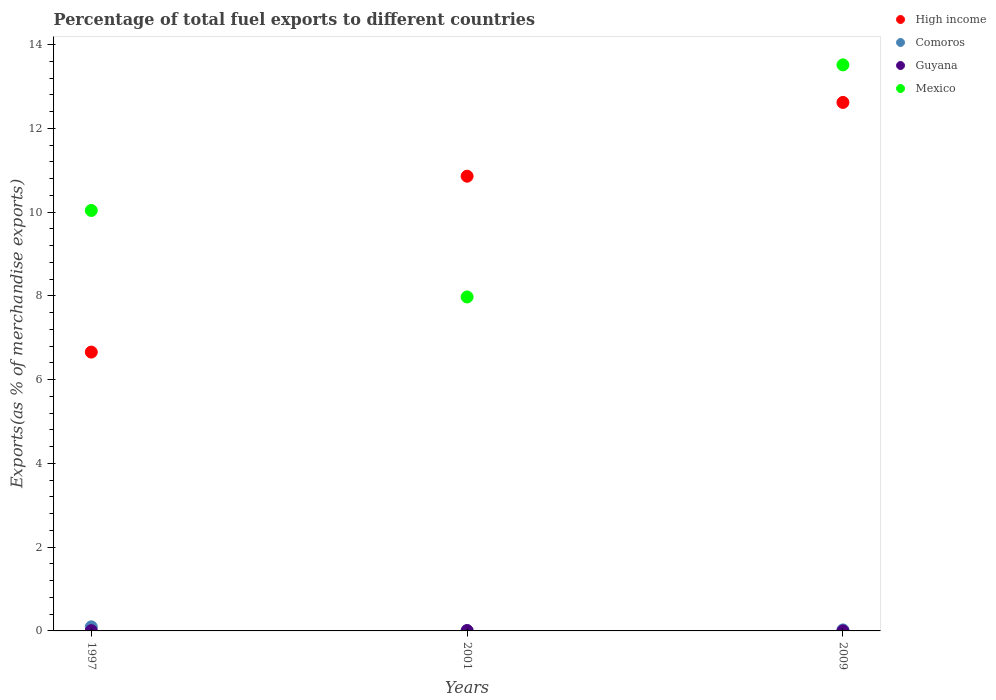Is the number of dotlines equal to the number of legend labels?
Your answer should be very brief. Yes. What is the percentage of exports to different countries in High income in 2009?
Give a very brief answer. 12.62. Across all years, what is the maximum percentage of exports to different countries in Mexico?
Keep it short and to the point. 13.51. Across all years, what is the minimum percentage of exports to different countries in Comoros?
Ensure brevity in your answer.  0. What is the total percentage of exports to different countries in Mexico in the graph?
Offer a terse response. 31.53. What is the difference between the percentage of exports to different countries in Comoros in 1997 and that in 2001?
Offer a terse response. 0.09. What is the difference between the percentage of exports to different countries in Mexico in 1997 and the percentage of exports to different countries in High income in 2001?
Give a very brief answer. -0.82. What is the average percentage of exports to different countries in Mexico per year?
Offer a very short reply. 10.51. In the year 2001, what is the difference between the percentage of exports to different countries in High income and percentage of exports to different countries in Guyana?
Keep it short and to the point. 10.85. In how many years, is the percentage of exports to different countries in High income greater than 12.8 %?
Your response must be concise. 0. What is the ratio of the percentage of exports to different countries in High income in 2001 to that in 2009?
Offer a very short reply. 0.86. Is the percentage of exports to different countries in Mexico in 1997 less than that in 2001?
Give a very brief answer. No. Is the difference between the percentage of exports to different countries in High income in 1997 and 2001 greater than the difference between the percentage of exports to different countries in Guyana in 1997 and 2001?
Ensure brevity in your answer.  No. What is the difference between the highest and the second highest percentage of exports to different countries in High income?
Offer a terse response. 1.76. What is the difference between the highest and the lowest percentage of exports to different countries in Mexico?
Your answer should be compact. 5.54. In how many years, is the percentage of exports to different countries in Guyana greater than the average percentage of exports to different countries in Guyana taken over all years?
Give a very brief answer. 2. Is it the case that in every year, the sum of the percentage of exports to different countries in Guyana and percentage of exports to different countries in Comoros  is greater than the sum of percentage of exports to different countries in High income and percentage of exports to different countries in Mexico?
Ensure brevity in your answer.  No. Is it the case that in every year, the sum of the percentage of exports to different countries in Guyana and percentage of exports to different countries in Comoros  is greater than the percentage of exports to different countries in Mexico?
Offer a very short reply. No. Does the percentage of exports to different countries in Mexico monotonically increase over the years?
Provide a succinct answer. No. Is the percentage of exports to different countries in High income strictly less than the percentage of exports to different countries in Guyana over the years?
Your answer should be compact. No. How many dotlines are there?
Offer a very short reply. 4. What is the difference between two consecutive major ticks on the Y-axis?
Offer a terse response. 2. Does the graph contain grids?
Offer a terse response. No. How are the legend labels stacked?
Offer a very short reply. Vertical. What is the title of the graph?
Offer a terse response. Percentage of total fuel exports to different countries. Does "Arab World" appear as one of the legend labels in the graph?
Make the answer very short. No. What is the label or title of the Y-axis?
Offer a very short reply. Exports(as % of merchandise exports). What is the Exports(as % of merchandise exports) in High income in 1997?
Your answer should be compact. 6.66. What is the Exports(as % of merchandise exports) in Comoros in 1997?
Make the answer very short. 0.1. What is the Exports(as % of merchandise exports) of Guyana in 1997?
Ensure brevity in your answer.  0.01. What is the Exports(as % of merchandise exports) in Mexico in 1997?
Ensure brevity in your answer.  10.04. What is the Exports(as % of merchandise exports) of High income in 2001?
Ensure brevity in your answer.  10.86. What is the Exports(as % of merchandise exports) of Comoros in 2001?
Give a very brief answer. 0. What is the Exports(as % of merchandise exports) in Guyana in 2001?
Your response must be concise. 0.01. What is the Exports(as % of merchandise exports) of Mexico in 2001?
Keep it short and to the point. 7.97. What is the Exports(as % of merchandise exports) in High income in 2009?
Your response must be concise. 12.62. What is the Exports(as % of merchandise exports) of Comoros in 2009?
Give a very brief answer. 0.02. What is the Exports(as % of merchandise exports) in Guyana in 2009?
Make the answer very short. 0. What is the Exports(as % of merchandise exports) in Mexico in 2009?
Offer a very short reply. 13.51. Across all years, what is the maximum Exports(as % of merchandise exports) in High income?
Your response must be concise. 12.62. Across all years, what is the maximum Exports(as % of merchandise exports) in Comoros?
Offer a terse response. 0.1. Across all years, what is the maximum Exports(as % of merchandise exports) in Guyana?
Give a very brief answer. 0.01. Across all years, what is the maximum Exports(as % of merchandise exports) in Mexico?
Keep it short and to the point. 13.51. Across all years, what is the minimum Exports(as % of merchandise exports) in High income?
Your response must be concise. 6.66. Across all years, what is the minimum Exports(as % of merchandise exports) of Comoros?
Keep it short and to the point. 0. Across all years, what is the minimum Exports(as % of merchandise exports) in Guyana?
Make the answer very short. 0. Across all years, what is the minimum Exports(as % of merchandise exports) of Mexico?
Give a very brief answer. 7.97. What is the total Exports(as % of merchandise exports) of High income in the graph?
Make the answer very short. 30.13. What is the total Exports(as % of merchandise exports) in Comoros in the graph?
Offer a very short reply. 0.13. What is the total Exports(as % of merchandise exports) in Guyana in the graph?
Keep it short and to the point. 0.01. What is the total Exports(as % of merchandise exports) of Mexico in the graph?
Your answer should be very brief. 31.53. What is the difference between the Exports(as % of merchandise exports) in High income in 1997 and that in 2001?
Provide a succinct answer. -4.2. What is the difference between the Exports(as % of merchandise exports) in Comoros in 1997 and that in 2001?
Ensure brevity in your answer.  0.09. What is the difference between the Exports(as % of merchandise exports) in Guyana in 1997 and that in 2001?
Ensure brevity in your answer.  -0. What is the difference between the Exports(as % of merchandise exports) in Mexico in 1997 and that in 2001?
Offer a terse response. 2.06. What is the difference between the Exports(as % of merchandise exports) of High income in 1997 and that in 2009?
Your answer should be very brief. -5.96. What is the difference between the Exports(as % of merchandise exports) in Comoros in 1997 and that in 2009?
Offer a very short reply. 0.07. What is the difference between the Exports(as % of merchandise exports) of Guyana in 1997 and that in 2009?
Your answer should be very brief. 0.01. What is the difference between the Exports(as % of merchandise exports) in Mexico in 1997 and that in 2009?
Your response must be concise. -3.48. What is the difference between the Exports(as % of merchandise exports) in High income in 2001 and that in 2009?
Provide a short and direct response. -1.76. What is the difference between the Exports(as % of merchandise exports) of Comoros in 2001 and that in 2009?
Provide a succinct answer. -0.02. What is the difference between the Exports(as % of merchandise exports) of Guyana in 2001 and that in 2009?
Give a very brief answer. 0.01. What is the difference between the Exports(as % of merchandise exports) of Mexico in 2001 and that in 2009?
Make the answer very short. -5.54. What is the difference between the Exports(as % of merchandise exports) in High income in 1997 and the Exports(as % of merchandise exports) in Comoros in 2001?
Keep it short and to the point. 6.65. What is the difference between the Exports(as % of merchandise exports) of High income in 1997 and the Exports(as % of merchandise exports) of Guyana in 2001?
Keep it short and to the point. 6.65. What is the difference between the Exports(as % of merchandise exports) of High income in 1997 and the Exports(as % of merchandise exports) of Mexico in 2001?
Provide a short and direct response. -1.32. What is the difference between the Exports(as % of merchandise exports) in Comoros in 1997 and the Exports(as % of merchandise exports) in Guyana in 2001?
Provide a succinct answer. 0.09. What is the difference between the Exports(as % of merchandise exports) of Comoros in 1997 and the Exports(as % of merchandise exports) of Mexico in 2001?
Your answer should be compact. -7.88. What is the difference between the Exports(as % of merchandise exports) of Guyana in 1997 and the Exports(as % of merchandise exports) of Mexico in 2001?
Keep it short and to the point. -7.97. What is the difference between the Exports(as % of merchandise exports) of High income in 1997 and the Exports(as % of merchandise exports) of Comoros in 2009?
Provide a short and direct response. 6.63. What is the difference between the Exports(as % of merchandise exports) of High income in 1997 and the Exports(as % of merchandise exports) of Guyana in 2009?
Offer a very short reply. 6.66. What is the difference between the Exports(as % of merchandise exports) in High income in 1997 and the Exports(as % of merchandise exports) in Mexico in 2009?
Provide a succinct answer. -6.86. What is the difference between the Exports(as % of merchandise exports) of Comoros in 1997 and the Exports(as % of merchandise exports) of Guyana in 2009?
Ensure brevity in your answer.  0.1. What is the difference between the Exports(as % of merchandise exports) in Comoros in 1997 and the Exports(as % of merchandise exports) in Mexico in 2009?
Provide a succinct answer. -13.42. What is the difference between the Exports(as % of merchandise exports) in Guyana in 1997 and the Exports(as % of merchandise exports) in Mexico in 2009?
Provide a short and direct response. -13.51. What is the difference between the Exports(as % of merchandise exports) in High income in 2001 and the Exports(as % of merchandise exports) in Comoros in 2009?
Your answer should be very brief. 10.83. What is the difference between the Exports(as % of merchandise exports) in High income in 2001 and the Exports(as % of merchandise exports) in Guyana in 2009?
Your answer should be very brief. 10.86. What is the difference between the Exports(as % of merchandise exports) in High income in 2001 and the Exports(as % of merchandise exports) in Mexico in 2009?
Offer a terse response. -2.66. What is the difference between the Exports(as % of merchandise exports) of Comoros in 2001 and the Exports(as % of merchandise exports) of Guyana in 2009?
Your answer should be very brief. 0. What is the difference between the Exports(as % of merchandise exports) of Comoros in 2001 and the Exports(as % of merchandise exports) of Mexico in 2009?
Provide a succinct answer. -13.51. What is the difference between the Exports(as % of merchandise exports) in Guyana in 2001 and the Exports(as % of merchandise exports) in Mexico in 2009?
Your answer should be very brief. -13.51. What is the average Exports(as % of merchandise exports) of High income per year?
Ensure brevity in your answer.  10.04. What is the average Exports(as % of merchandise exports) in Comoros per year?
Provide a succinct answer. 0.04. What is the average Exports(as % of merchandise exports) in Guyana per year?
Offer a very short reply. 0. What is the average Exports(as % of merchandise exports) of Mexico per year?
Your answer should be compact. 10.51. In the year 1997, what is the difference between the Exports(as % of merchandise exports) in High income and Exports(as % of merchandise exports) in Comoros?
Your answer should be very brief. 6.56. In the year 1997, what is the difference between the Exports(as % of merchandise exports) in High income and Exports(as % of merchandise exports) in Guyana?
Provide a short and direct response. 6.65. In the year 1997, what is the difference between the Exports(as % of merchandise exports) in High income and Exports(as % of merchandise exports) in Mexico?
Make the answer very short. -3.38. In the year 1997, what is the difference between the Exports(as % of merchandise exports) in Comoros and Exports(as % of merchandise exports) in Guyana?
Ensure brevity in your answer.  0.09. In the year 1997, what is the difference between the Exports(as % of merchandise exports) in Comoros and Exports(as % of merchandise exports) in Mexico?
Your answer should be very brief. -9.94. In the year 1997, what is the difference between the Exports(as % of merchandise exports) in Guyana and Exports(as % of merchandise exports) in Mexico?
Provide a succinct answer. -10.03. In the year 2001, what is the difference between the Exports(as % of merchandise exports) in High income and Exports(as % of merchandise exports) in Comoros?
Provide a succinct answer. 10.85. In the year 2001, what is the difference between the Exports(as % of merchandise exports) in High income and Exports(as % of merchandise exports) in Guyana?
Offer a terse response. 10.85. In the year 2001, what is the difference between the Exports(as % of merchandise exports) in High income and Exports(as % of merchandise exports) in Mexico?
Keep it short and to the point. 2.88. In the year 2001, what is the difference between the Exports(as % of merchandise exports) in Comoros and Exports(as % of merchandise exports) in Guyana?
Provide a short and direct response. -0. In the year 2001, what is the difference between the Exports(as % of merchandise exports) in Comoros and Exports(as % of merchandise exports) in Mexico?
Keep it short and to the point. -7.97. In the year 2001, what is the difference between the Exports(as % of merchandise exports) in Guyana and Exports(as % of merchandise exports) in Mexico?
Your answer should be very brief. -7.97. In the year 2009, what is the difference between the Exports(as % of merchandise exports) of High income and Exports(as % of merchandise exports) of Comoros?
Offer a very short reply. 12.59. In the year 2009, what is the difference between the Exports(as % of merchandise exports) of High income and Exports(as % of merchandise exports) of Guyana?
Keep it short and to the point. 12.62. In the year 2009, what is the difference between the Exports(as % of merchandise exports) of High income and Exports(as % of merchandise exports) of Mexico?
Offer a very short reply. -0.9. In the year 2009, what is the difference between the Exports(as % of merchandise exports) of Comoros and Exports(as % of merchandise exports) of Guyana?
Your response must be concise. 0.02. In the year 2009, what is the difference between the Exports(as % of merchandise exports) of Comoros and Exports(as % of merchandise exports) of Mexico?
Keep it short and to the point. -13.49. In the year 2009, what is the difference between the Exports(as % of merchandise exports) of Guyana and Exports(as % of merchandise exports) of Mexico?
Your response must be concise. -13.51. What is the ratio of the Exports(as % of merchandise exports) in High income in 1997 to that in 2001?
Keep it short and to the point. 0.61. What is the ratio of the Exports(as % of merchandise exports) in Comoros in 1997 to that in 2001?
Your answer should be very brief. 20.8. What is the ratio of the Exports(as % of merchandise exports) in Guyana in 1997 to that in 2001?
Provide a succinct answer. 0.72. What is the ratio of the Exports(as % of merchandise exports) of Mexico in 1997 to that in 2001?
Make the answer very short. 1.26. What is the ratio of the Exports(as % of merchandise exports) of High income in 1997 to that in 2009?
Keep it short and to the point. 0.53. What is the ratio of the Exports(as % of merchandise exports) of Comoros in 1997 to that in 2009?
Provide a short and direct response. 4.1. What is the ratio of the Exports(as % of merchandise exports) of Guyana in 1997 to that in 2009?
Keep it short and to the point. 21. What is the ratio of the Exports(as % of merchandise exports) of Mexico in 1997 to that in 2009?
Your answer should be very brief. 0.74. What is the ratio of the Exports(as % of merchandise exports) of High income in 2001 to that in 2009?
Offer a very short reply. 0.86. What is the ratio of the Exports(as % of merchandise exports) in Comoros in 2001 to that in 2009?
Make the answer very short. 0.2. What is the ratio of the Exports(as % of merchandise exports) of Guyana in 2001 to that in 2009?
Give a very brief answer. 29.33. What is the ratio of the Exports(as % of merchandise exports) of Mexico in 2001 to that in 2009?
Provide a short and direct response. 0.59. What is the difference between the highest and the second highest Exports(as % of merchandise exports) in High income?
Your answer should be compact. 1.76. What is the difference between the highest and the second highest Exports(as % of merchandise exports) in Comoros?
Your answer should be very brief. 0.07. What is the difference between the highest and the second highest Exports(as % of merchandise exports) in Guyana?
Keep it short and to the point. 0. What is the difference between the highest and the second highest Exports(as % of merchandise exports) in Mexico?
Provide a short and direct response. 3.48. What is the difference between the highest and the lowest Exports(as % of merchandise exports) in High income?
Ensure brevity in your answer.  5.96. What is the difference between the highest and the lowest Exports(as % of merchandise exports) in Comoros?
Make the answer very short. 0.09. What is the difference between the highest and the lowest Exports(as % of merchandise exports) of Guyana?
Provide a succinct answer. 0.01. What is the difference between the highest and the lowest Exports(as % of merchandise exports) of Mexico?
Give a very brief answer. 5.54. 